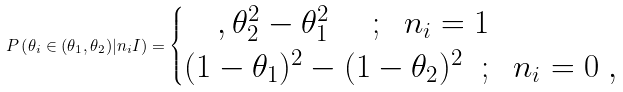<formula> <loc_0><loc_0><loc_500><loc_500>P \left ( \theta _ { i } \in ( \theta _ { 1 } , \theta _ { 2 } ) | n _ { i } I \right ) = \begin{cases} \quad , \theta _ { 2 } ^ { 2 } - \theta _ { 1 } ^ { 2 } \quad \ ; \ \ n _ { i } = 1 \\ ( 1 - \theta _ { 1 } ) ^ { 2 } - ( 1 - \theta _ { 2 } ) ^ { 2 } \ \ ; \ \ n _ { i } = 0 \ , \end{cases}</formula> 